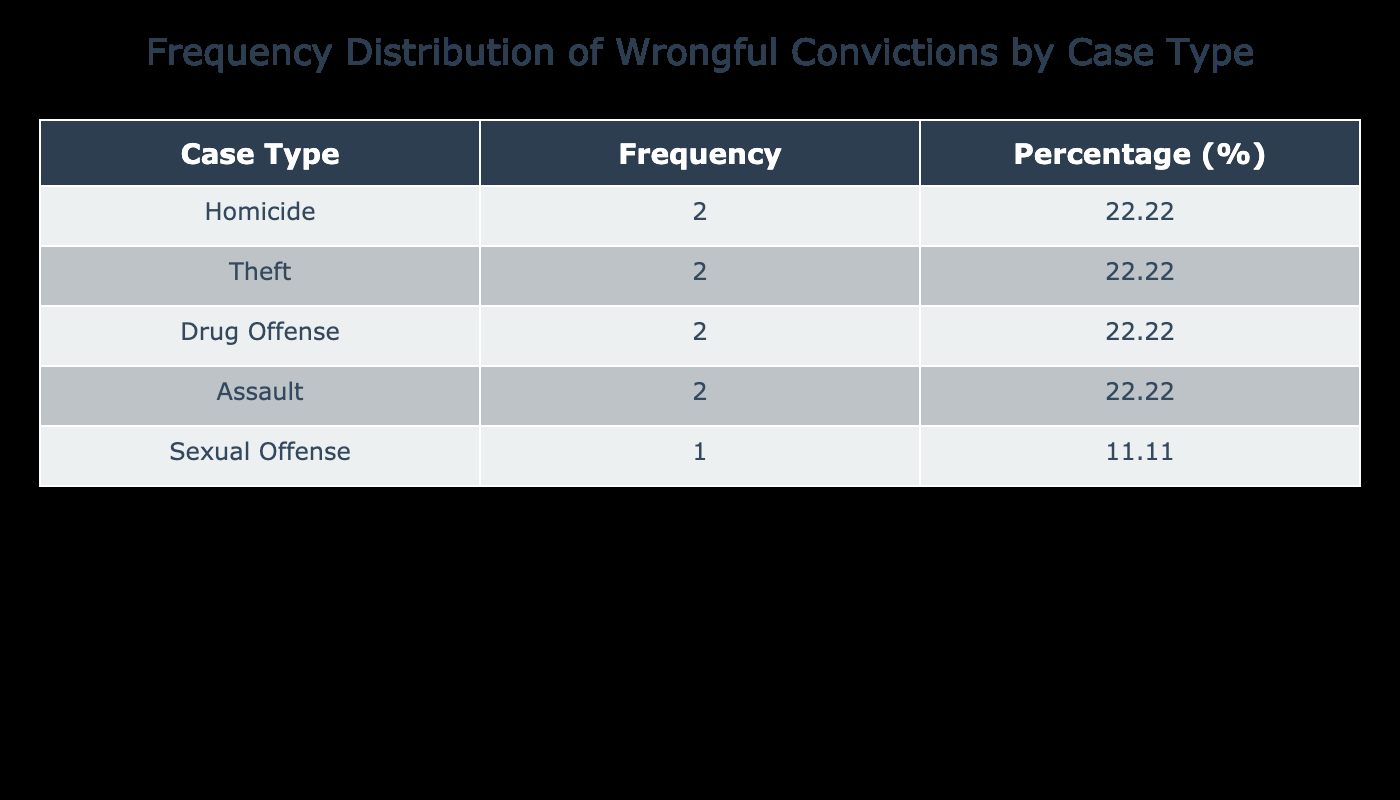What is the most common case type associated with wrongful convictions? By examining the table, we look for the case type with the highest frequency. The values indicate that "Homicide," "Theft," and "Drug Offense" each have 3 incidents recorded, but "Sexual Offense" with 4 wrongful convictions is the highest. Therefore, the most common case type is "Sexual Offense."
Answer: Sexual Offense How many cases of wrongful convictions were recorded for assaults? The table indicates there are two rows related to "Assault." Summing the instances gives us 1 case from 2018 and 3 from 2023, leading to a total of 1 + 3 = 4 cases of assault-related wrongful convictions.
Answer: 4 What percentage of total wrongful convictions were related to theft? First, we find the frequency of "Theft," which appears 2 times in the table. To find the percentage, calculate the total number of wrongful convictions: 2 (Homicide) + 1 (Theft) + 3 (Drug Offense) + 1 (Assault) + 2 (Homicide) + 4 (Sexual Offense) + 2 (Theft) + 1 (Drug Offense) + 3 (Assault) = 19. Now, the percentage = (2 / 19) * 100 = approximately 10.53%.
Answer: 10.53% Did any case type see a correctional outcome of "Exonerated" that had more than 2 wrongful convictions? By reviewing the table, we see that "Sexual Offense" had 4 instances and was marked as "Exonerated." This leads to the conclusion that at least one case type had more than 2 wrongful convictions with this outcome, making the answer 'true.'
Answer: Yes If we look at all "Exonerated" cases, what is the average number of wrongful convictions per type? The cases associated with "Exonerated" include: 2 (Homicide) in 2015, 3 (Drug Offense) in 2017, 2 (Homicide) in 2019, 4 (Sexual Offense) in 2020, and 1 (Drug Offense) in 2022. Summing these values gives us 2 + 3 + 2 + 4 + 1 = 12. With 5 types of cases, the average is 12 / 5 = 2.4.
Answer: 2.4 